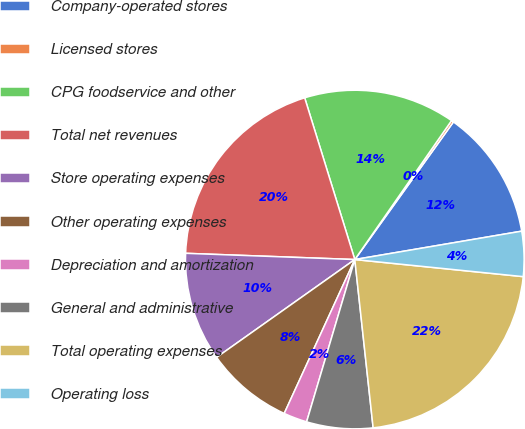<chart> <loc_0><loc_0><loc_500><loc_500><pie_chart><fcel>Company-operated stores<fcel>Licensed stores<fcel>CPG foodservice and other<fcel>Total net revenues<fcel>Store operating expenses<fcel>Other operating expenses<fcel>Depreciation and amortization<fcel>General and administrative<fcel>Total operating expenses<fcel>Operating loss<nl><fcel>12.42%<fcel>0.22%<fcel>14.46%<fcel>19.63%<fcel>10.39%<fcel>8.35%<fcel>2.25%<fcel>6.32%<fcel>21.66%<fcel>4.29%<nl></chart> 